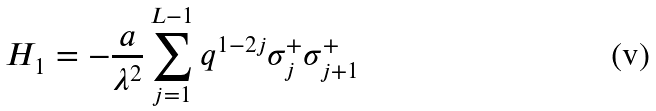Convert formula to latex. <formula><loc_0><loc_0><loc_500><loc_500>H _ { 1 } = - \frac { a } { \lambda ^ { 2 } } \sum ^ { L - 1 } _ { j = 1 } q ^ { 1 - 2 j } \sigma ^ { + } _ { j } \sigma ^ { + } _ { j + 1 }</formula> 